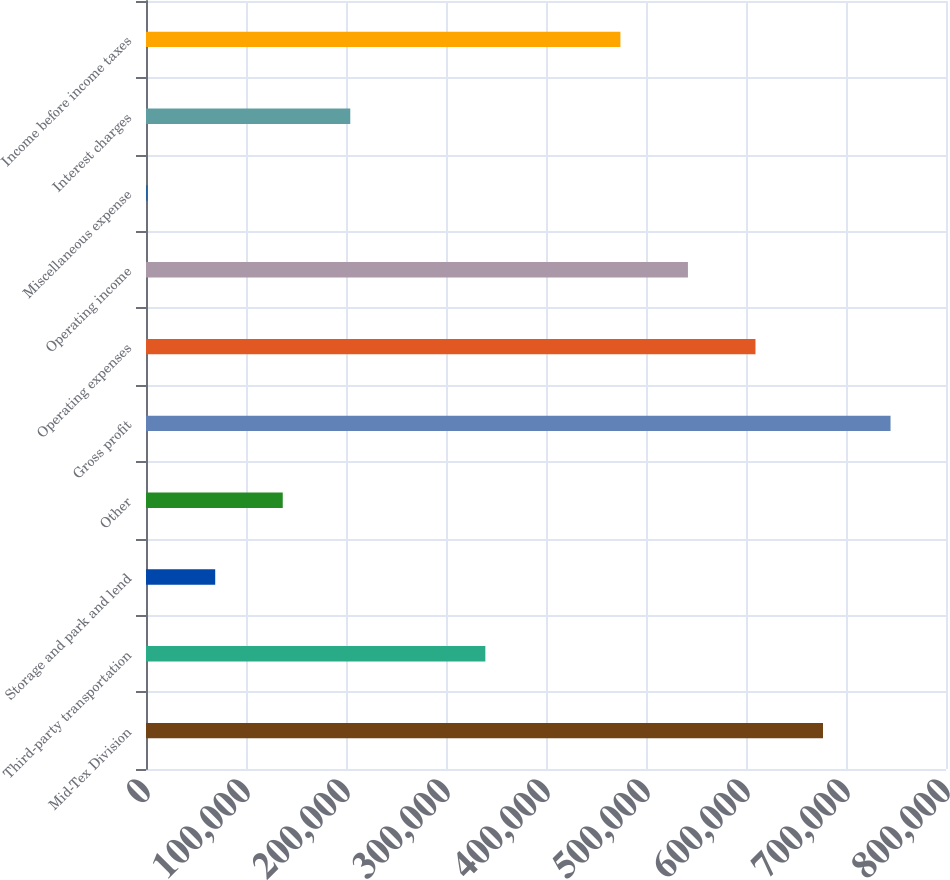Convert chart to OTSL. <chart><loc_0><loc_0><loc_500><loc_500><bar_chart><fcel>Mid-Tex Division<fcel>Third-party transportation<fcel>Storage and park and lend<fcel>Other<fcel>Gross profit<fcel>Operating expenses<fcel>Operating income<fcel>Miscellaneous expense<fcel>Interest charges<fcel>Income before income taxes<nl><fcel>677001<fcel>339342<fcel>69214.8<fcel>136747<fcel>744533<fcel>609469<fcel>541937<fcel>1683<fcel>204278<fcel>474406<nl></chart> 